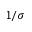<formula> <loc_0><loc_0><loc_500><loc_500>1 / \sigma</formula> 